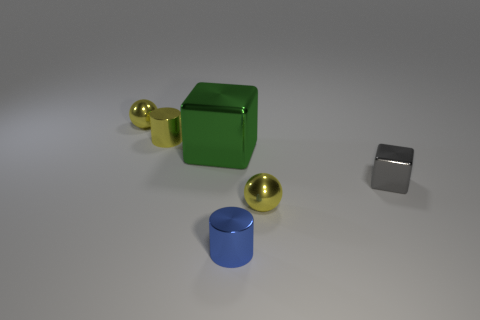Subtract all blocks. How many objects are left? 4 Add 2 big gray shiny cylinders. How many objects exist? 8 Subtract all gray cubes. How many cubes are left? 1 Subtract all red balls. How many blue cylinders are left? 1 Subtract all small gray things. Subtract all large green things. How many objects are left? 4 Add 6 cylinders. How many cylinders are left? 8 Add 2 small gray matte balls. How many small gray matte balls exist? 2 Subtract 0 purple cylinders. How many objects are left? 6 Subtract 1 cylinders. How many cylinders are left? 1 Subtract all green cubes. Subtract all green balls. How many cubes are left? 1 